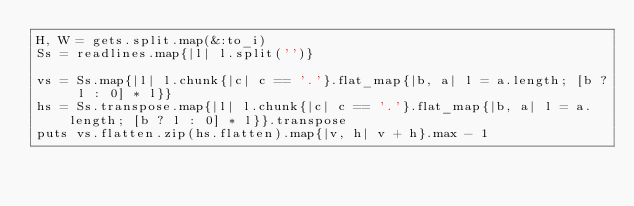<code> <loc_0><loc_0><loc_500><loc_500><_Ruby_>H, W = gets.split.map(&:to_i)
Ss = readlines.map{|l| l.split('')}

vs = Ss.map{|l| l.chunk{|c| c == '.'}.flat_map{|b, a| l = a.length; [b ? l : 0] * l}}
hs = Ss.transpose.map{|l| l.chunk{|c| c == '.'}.flat_map{|b, a| l = a.length; [b ? l : 0] * l}}.transpose
puts vs.flatten.zip(hs.flatten).map{|v, h| v + h}.max - 1</code> 